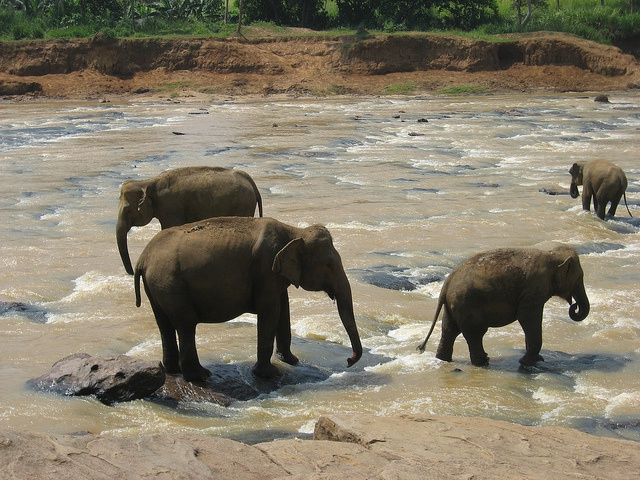Describe the objects in this image and their specific colors. I can see elephant in black and gray tones, elephant in black and gray tones, elephant in black and gray tones, and elephant in black and gray tones in this image. 